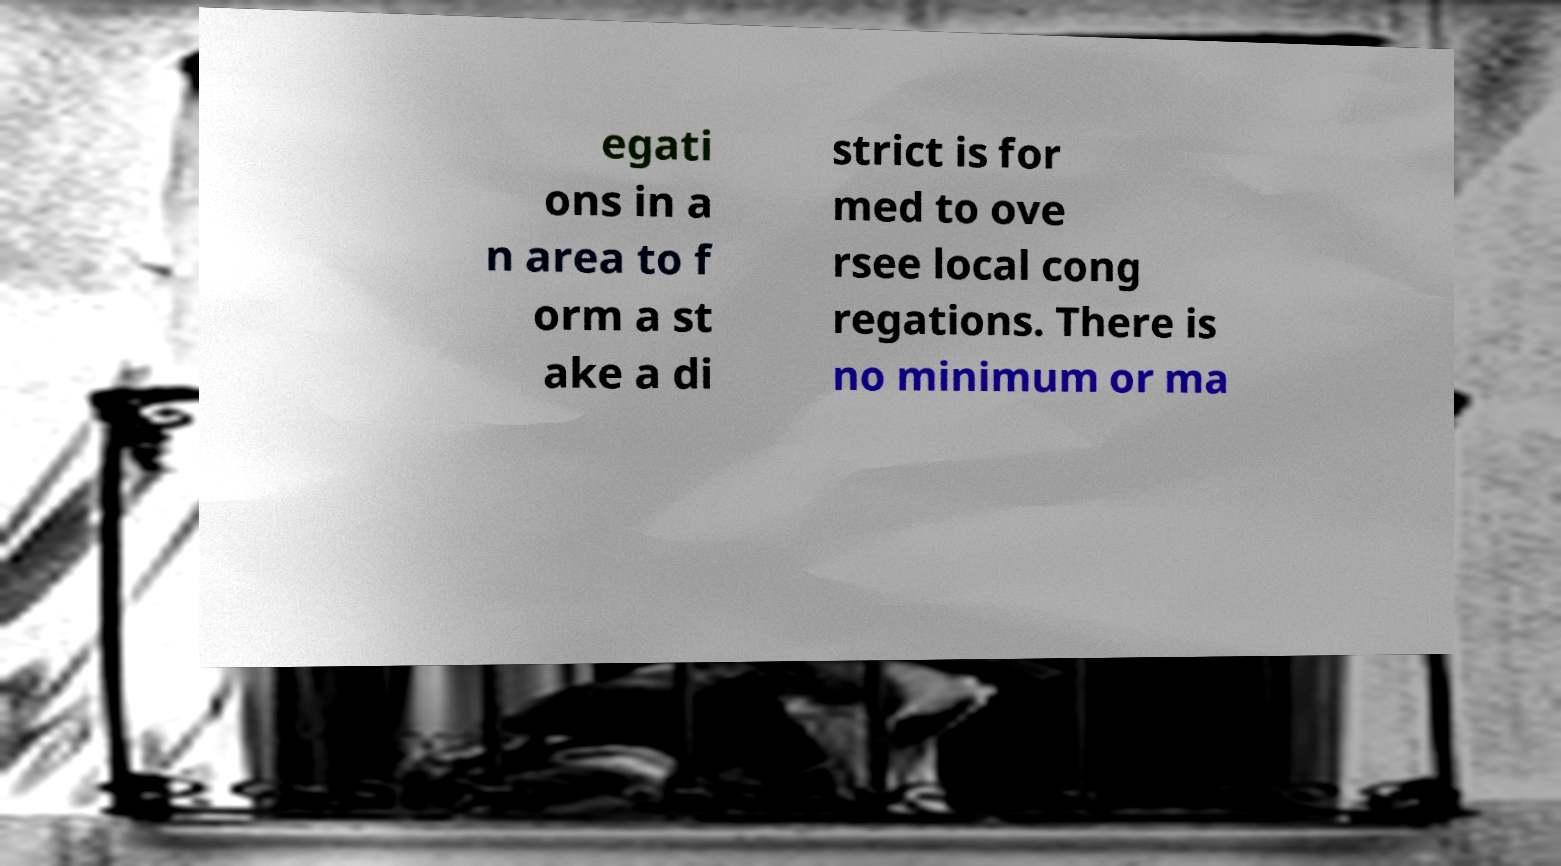Please identify and transcribe the text found in this image. egati ons in a n area to f orm a st ake a di strict is for med to ove rsee local cong regations. There is no minimum or ma 